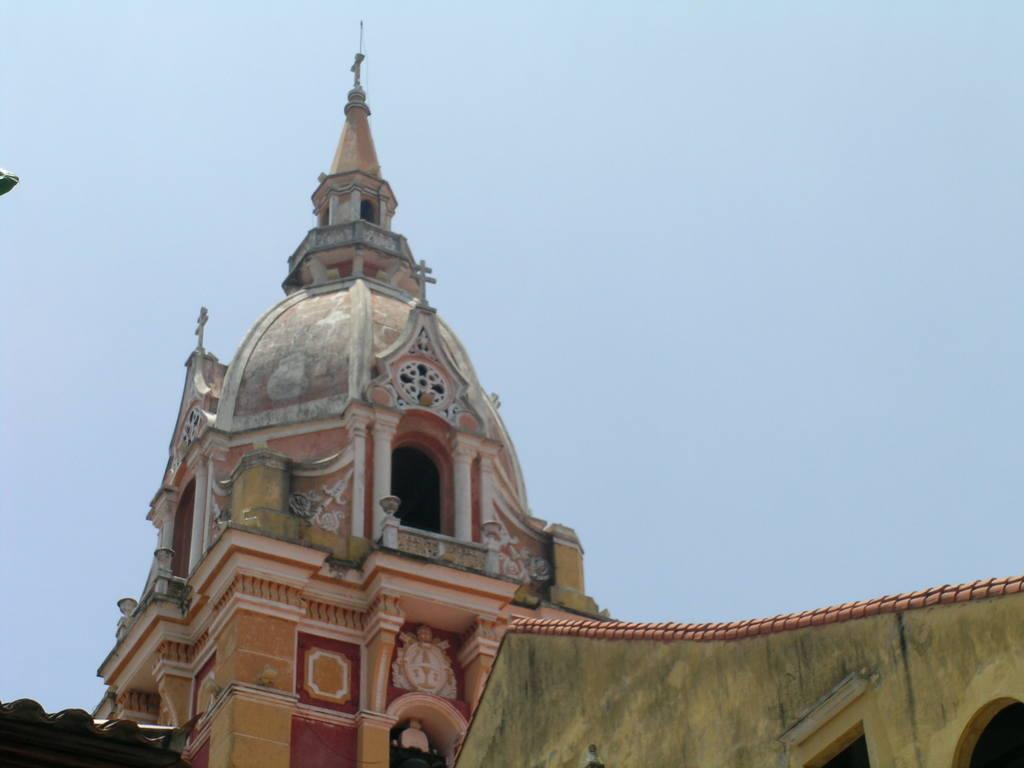What structures are visible in the closest to the viewer in the image? There are roofs of houses and a dome of a building in the foreground of the image. Can you describe the sky in the image? The sky is visible in the background of the image. What type of dirt can be seen in the image? There is no dirt visible in the image; it primarily features roofs, a dome, and the sky. Are there any fowl present in the image? There is no mention of fowl in the provided facts, and therefore no such presence can be confirmed. 